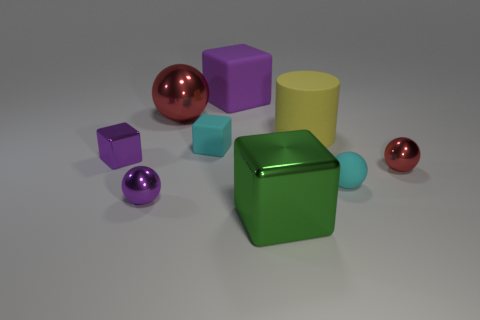Add 1 big green shiny cubes. How many objects exist? 10 Subtract all blue spheres. Subtract all brown cubes. How many spheres are left? 4 Subtract all balls. How many objects are left? 5 Subtract all cyan things. Subtract all tiny yellow shiny cylinders. How many objects are left? 7 Add 8 small red objects. How many small red objects are left? 9 Add 6 green cubes. How many green cubes exist? 7 Subtract 0 red blocks. How many objects are left? 9 